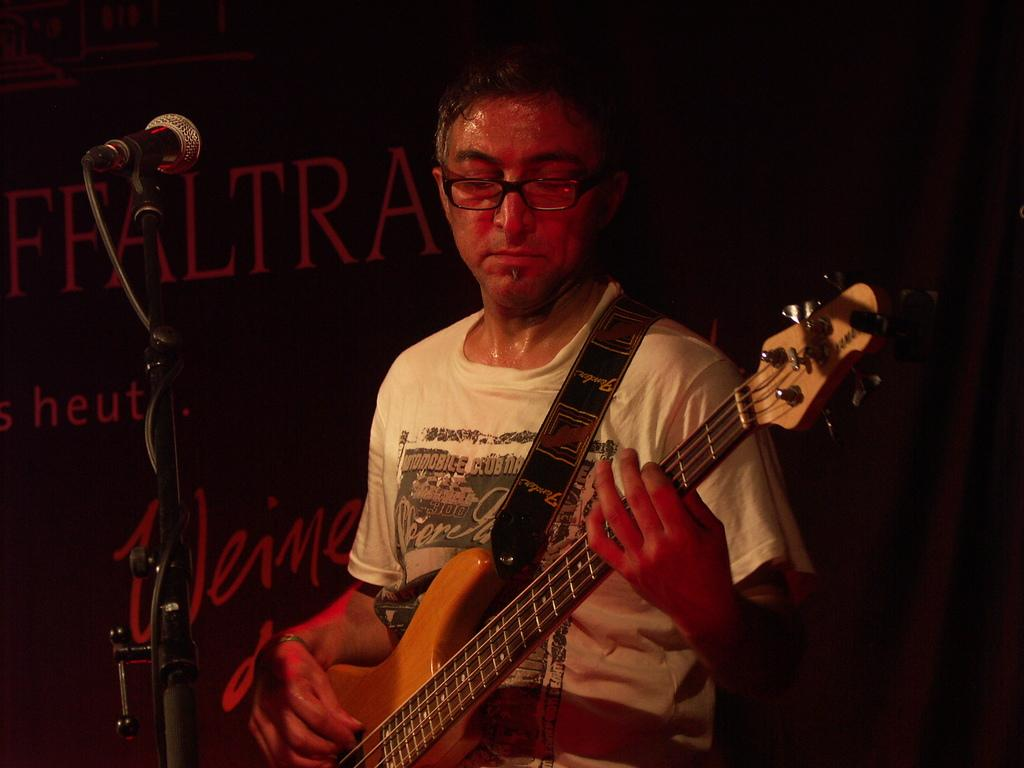What is the man in the image doing? The man is playing a guitar. What is the man wearing in the image? The man is wearing a white t-shirt and glasses. What object is in front of the man in the image? There is a microphone in front of the man. What can be seen in the background of the image? There is a banner and a curtain in the background. Where is the playground located in the image? There is no playground present in the image. Who is the man's uncle in the image? The image does not provide any information about the man's family, so it is impossible to determine who his uncle is. 